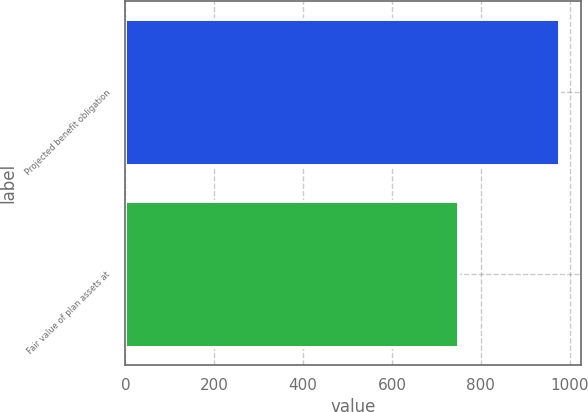<chart> <loc_0><loc_0><loc_500><loc_500><bar_chart><fcel>Projected benefit obligation<fcel>Fair value of plan assets at<nl><fcel>976<fcel>749<nl></chart> 